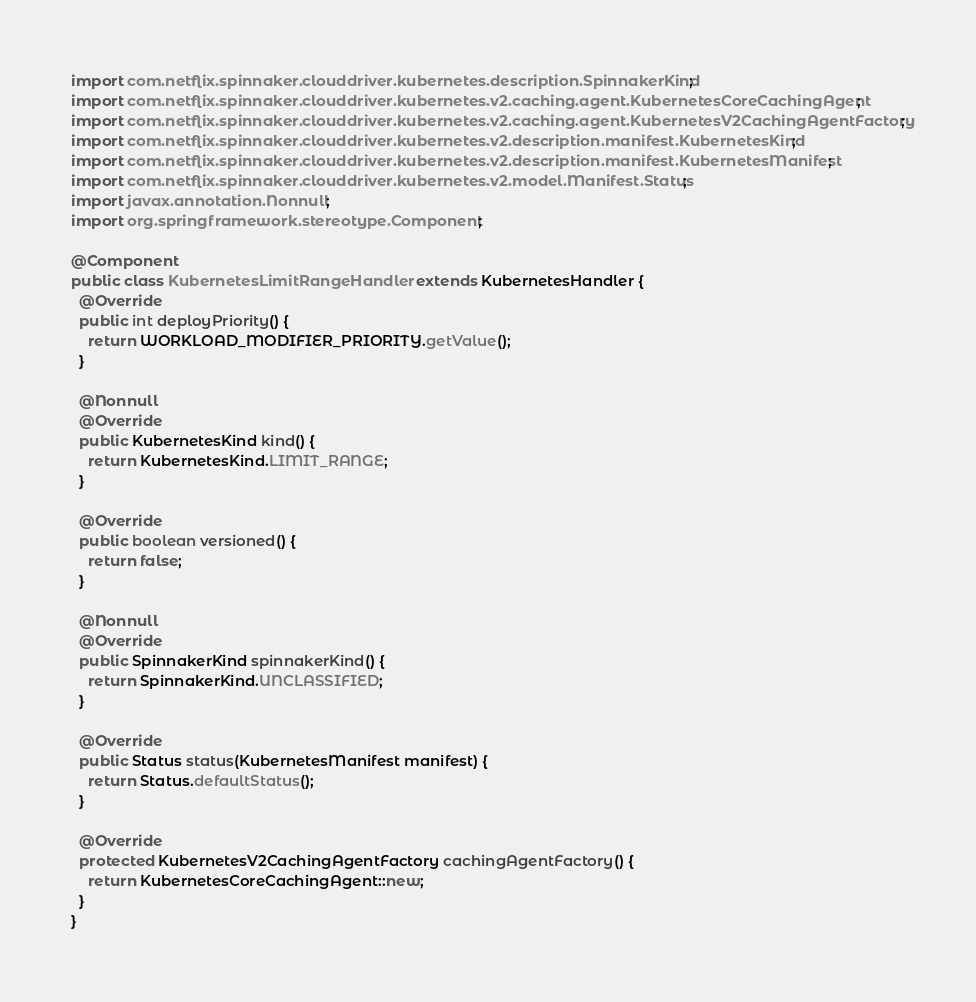Convert code to text. <code><loc_0><loc_0><loc_500><loc_500><_Java_>import com.netflix.spinnaker.clouddriver.kubernetes.description.SpinnakerKind;
import com.netflix.spinnaker.clouddriver.kubernetes.v2.caching.agent.KubernetesCoreCachingAgent;
import com.netflix.spinnaker.clouddriver.kubernetes.v2.caching.agent.KubernetesV2CachingAgentFactory;
import com.netflix.spinnaker.clouddriver.kubernetes.v2.description.manifest.KubernetesKind;
import com.netflix.spinnaker.clouddriver.kubernetes.v2.description.manifest.KubernetesManifest;
import com.netflix.spinnaker.clouddriver.kubernetes.v2.model.Manifest.Status;
import javax.annotation.Nonnull;
import org.springframework.stereotype.Component;

@Component
public class KubernetesLimitRangeHandler extends KubernetesHandler {
  @Override
  public int deployPriority() {
    return WORKLOAD_MODIFIER_PRIORITY.getValue();
  }

  @Nonnull
  @Override
  public KubernetesKind kind() {
    return KubernetesKind.LIMIT_RANGE;
  }

  @Override
  public boolean versioned() {
    return false;
  }

  @Nonnull
  @Override
  public SpinnakerKind spinnakerKind() {
    return SpinnakerKind.UNCLASSIFIED;
  }

  @Override
  public Status status(KubernetesManifest manifest) {
    return Status.defaultStatus();
  }

  @Override
  protected KubernetesV2CachingAgentFactory cachingAgentFactory() {
    return KubernetesCoreCachingAgent::new;
  }
}
</code> 